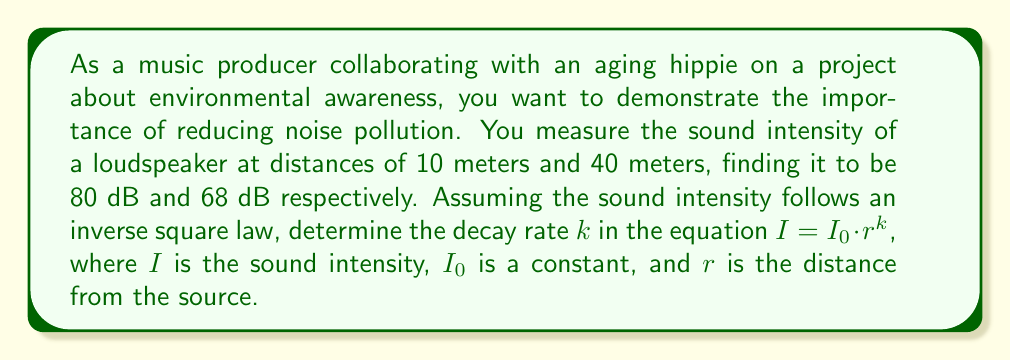Help me with this question. 1) The inverse square law for sound intensity is given by $I = I_0 \cdot r^k$, where $k$ is the decay rate we need to find.

2) We can use the two measurements to set up an equation:
   $\frac{I_1}{I_2} = \left(\frac{r_2}{r_1}\right)^k$

3) Sound intensity in decibels (dB) is related to power by:
   $dB = 10 \log_{10}\left(\frac{I}{I_{ref}}\right)$

4) We can convert this to a ratio:
   $\frac{I_1}{I_2} = 10^{\frac{dB_1 - dB_2}{10}}$

5) Substituting our values:
   $10^{\frac{80 - 68}{10}} = \left(\frac{40}{10}\right)^k$

6) Simplify:
   $10^{1.2} = 4^k$

7) Take the logarithm of both sides:
   $1.2 \log(10) = k \log(4)$

8) Solve for $k$:
   $k = \frac{1.2 \log(10)}{\log(4)} \approx -2$

The negative sign indicates that the intensity decreases with distance.
Answer: $k \approx -2$ 